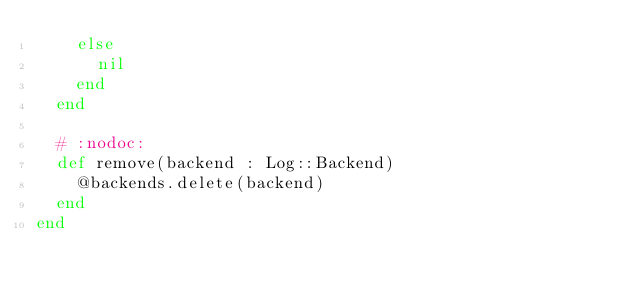Convert code to text. <code><loc_0><loc_0><loc_500><loc_500><_Crystal_>    else
      nil
    end
  end

  # :nodoc:
  def remove(backend : Log::Backend)
    @backends.delete(backend)
  end
end
</code> 